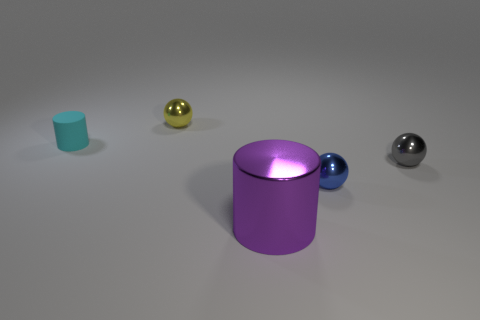There is a small thing that is in front of the small yellow metal ball and left of the big purple cylinder; what material is it made of?
Provide a succinct answer. Rubber. Are there any red metal cylinders?
Your answer should be compact. No. There is a tiny cyan rubber object that is on the left side of the big metal object that is in front of the thing that is on the left side of the yellow shiny object; what shape is it?
Ensure brevity in your answer.  Cylinder. The small cyan object has what shape?
Ensure brevity in your answer.  Cylinder. What is the color of the small metallic thing to the left of the large metallic thing?
Ensure brevity in your answer.  Yellow. Do the ball that is in front of the gray ball and the small cyan cylinder have the same size?
Your answer should be very brief. Yes. The yellow object that is the same shape as the gray shiny thing is what size?
Make the answer very short. Small. Is there any other thing that is the same size as the purple cylinder?
Your response must be concise. No. Is the shape of the gray object the same as the yellow metallic object?
Make the answer very short. Yes. Are there fewer blue spheres in front of the small blue thing than cyan matte cylinders that are behind the cyan rubber thing?
Your answer should be compact. No. 